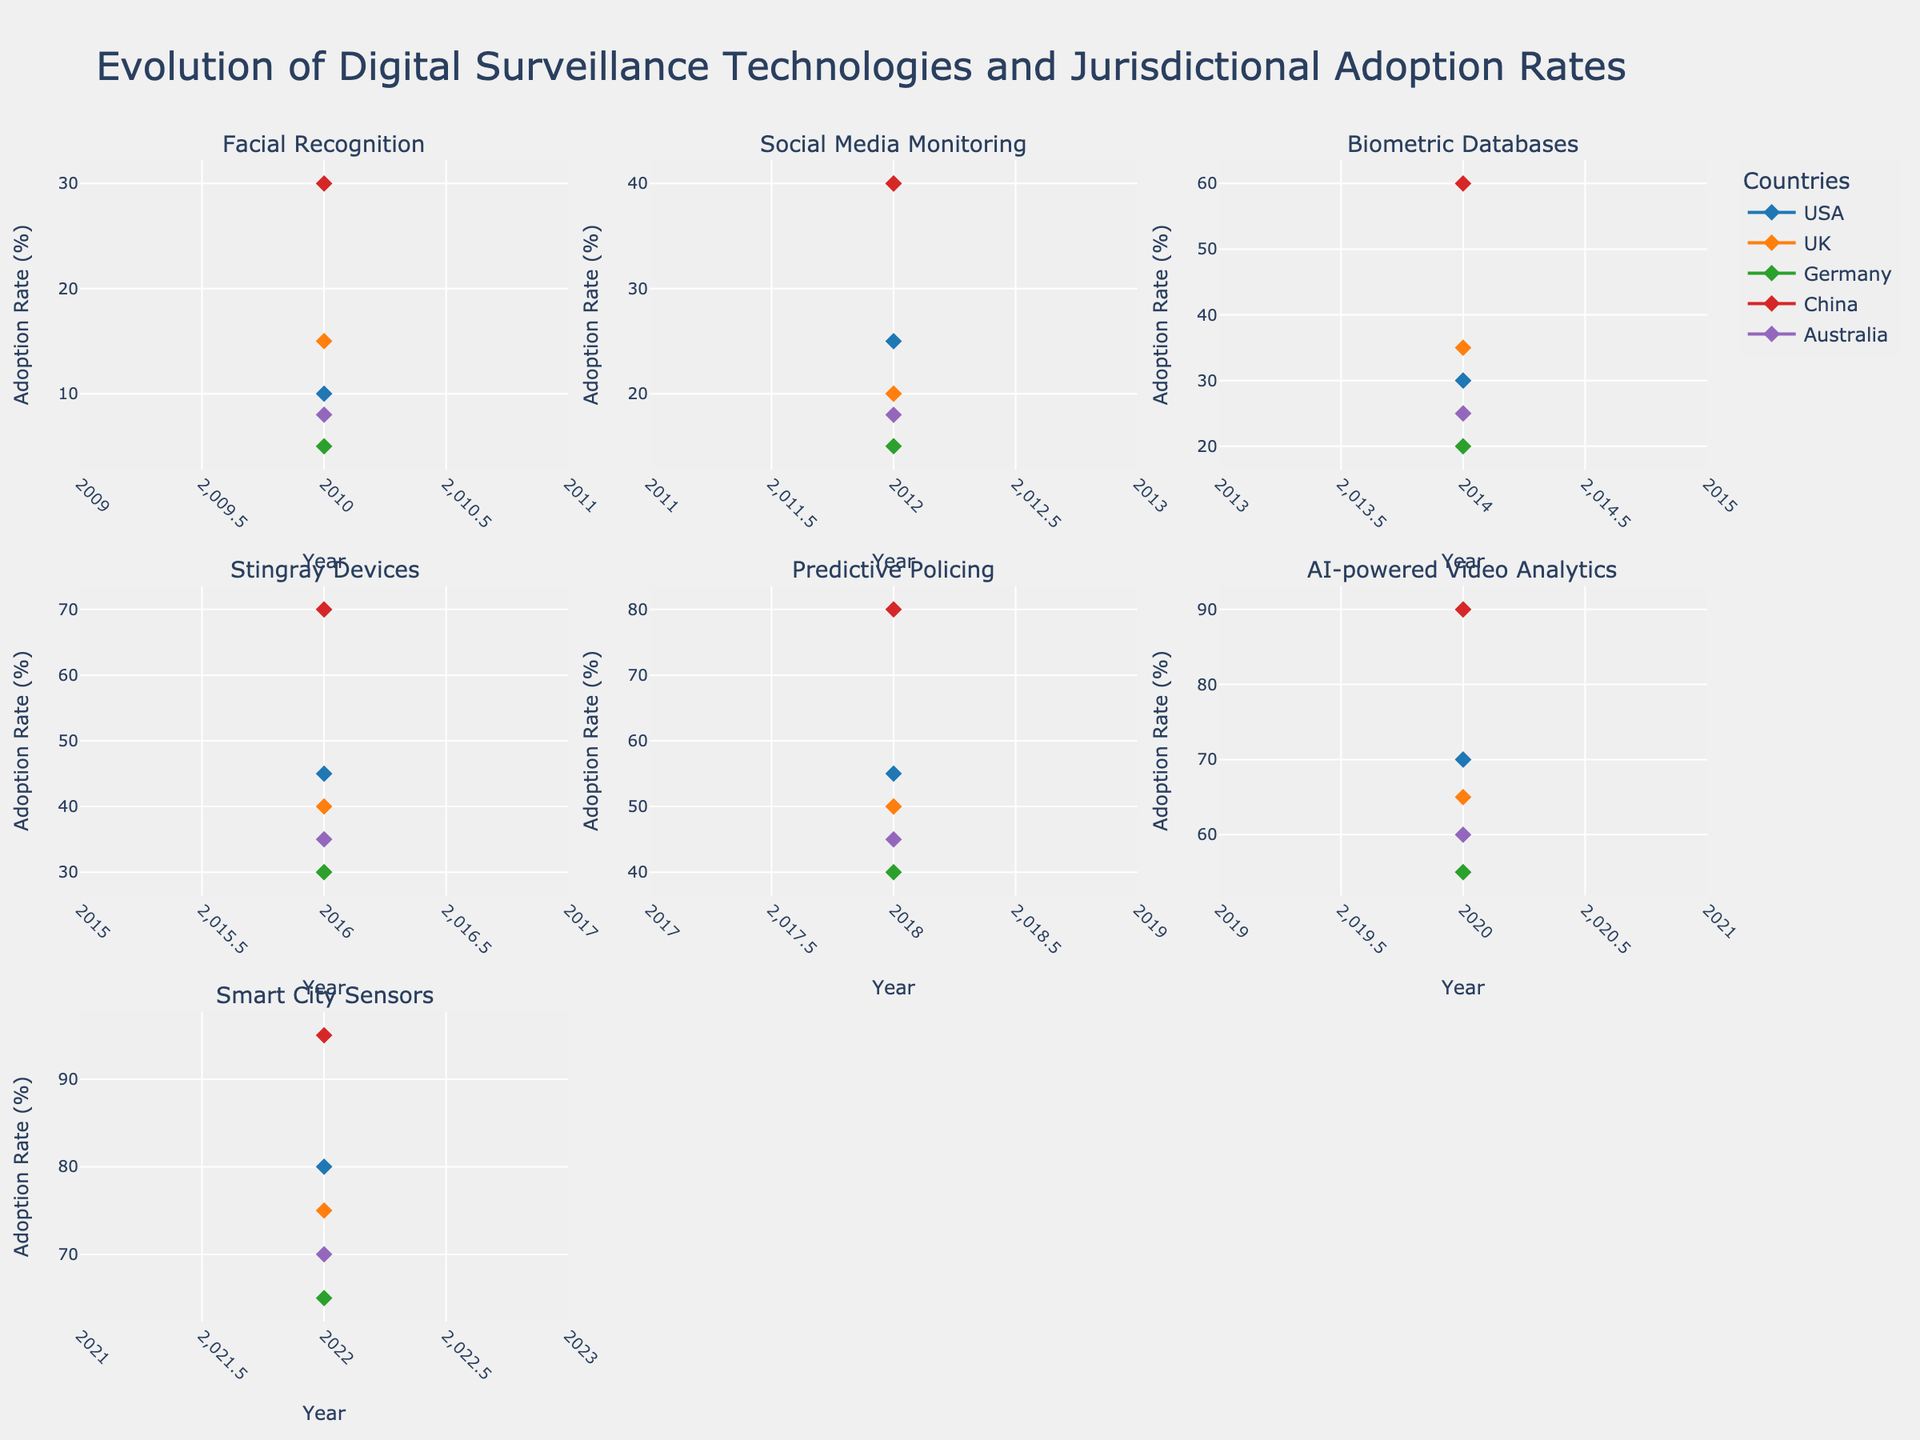What is the title of the figure? The title of the figure is located at the top and provides an overarching description of the visualized data. It reads as follows: "Evolution of Digital Surveillance Technologies and Jurisdictional Adoption Rates".
Answer: Evolution of Digital Surveillance Technologies and Jurisdictional Adoption Rates How many countries are represented in each subplot? Each subplot has lines representing different countries. There are five lines, one for each country: USA, UK, Germany, China, and Australia.
Answer: 5 Which country had the highest adoption rate for Facial Recognition in 2010? By looking at the subplot titled "Facial Recognition" and focusing on the year 2010, we can see that China had the highest adoption rate, represented by the highest line for that year.
Answer: China Did the adoption rate of Predictive Policing in the USA exceed 50% in 2018? By examining the subplot titled "Predictive Policing" and checking the line corresponding to the USA for the year 2018, we can confirm that the adoption rate was 55%, which exceeds 50%.
Answer: Yes What is the average adoption rate of AI-powered Video Analytics in 2020 across all countries? For this we need to sum the adoption rates of AI-powered Video Analytics in 2020 for all countries (USA: 70, UK: 65, Germany: 55, China: 90, Australia: 60) and divide by the number of countries, which is 5. The calculation is (70 + 65 + 55 + 90 + 60) / 5 = 68%.
Answer: 68% Which technology had the largest increase in adoption rate in the UK from 2010 to 2022? We need to compare the first and last years (2010 and 2022) of each technology in the UK. Facial Recognition increased from 15% to 75%, Social Media Monitoring from 20% to 75%, Biometric Databases from 35% to 75%, Stingray Devices from 40% to 75%, Predictive Policing from 50% to 75%, AI-powered Video Analytics from 65% to 75%, and Smart City Sensors from 75% to 75%. The largest increase is seen in AI-powered Video Analytics, with a 60% increase (75% - 15%).
Answer: AI-powered Video Analytics How did the adoption rate of Smart City Sensors in China change from 2010 to 2022? By inspecting the subplot titled "Smart City Sensors" and looking at the line for China, we see it went from 30% in 2010 to 95% in 2022. The change is calculated by 95% - 30% = 65%.
Answer: Increased by 65% Is there any technology for which Germany's adoption rate remains consistently the lowest among all countries throughout the years? We need to examine each subplot and compare Germany's line with others'. For Facial Recognition, Germany is lower than all others. This is also true for Social Media Monitoring, Biometric Databases, Stingray Devices, Predictive Policing, and AI-powered Video Analytics. However, for Smart City Sensors, Germany's rate is higher than the USA's initially. Therefore, no single technology consistently has the lowest adoption rate for Germany across all years.
Answer: No Which two technologies show the most significant change in adoption rate for Australia from 2012 to 2020? Observing subplots for Australia and comparing years 2012 and 2020, Social Media Monitoring increased by (60% - 18% = 42%), AI-powered Video Analytics increased by (60% - 0% = 60%). These two show the largest changes.
Answer: AI-powered Video Analytics and Social Media Monitoring 